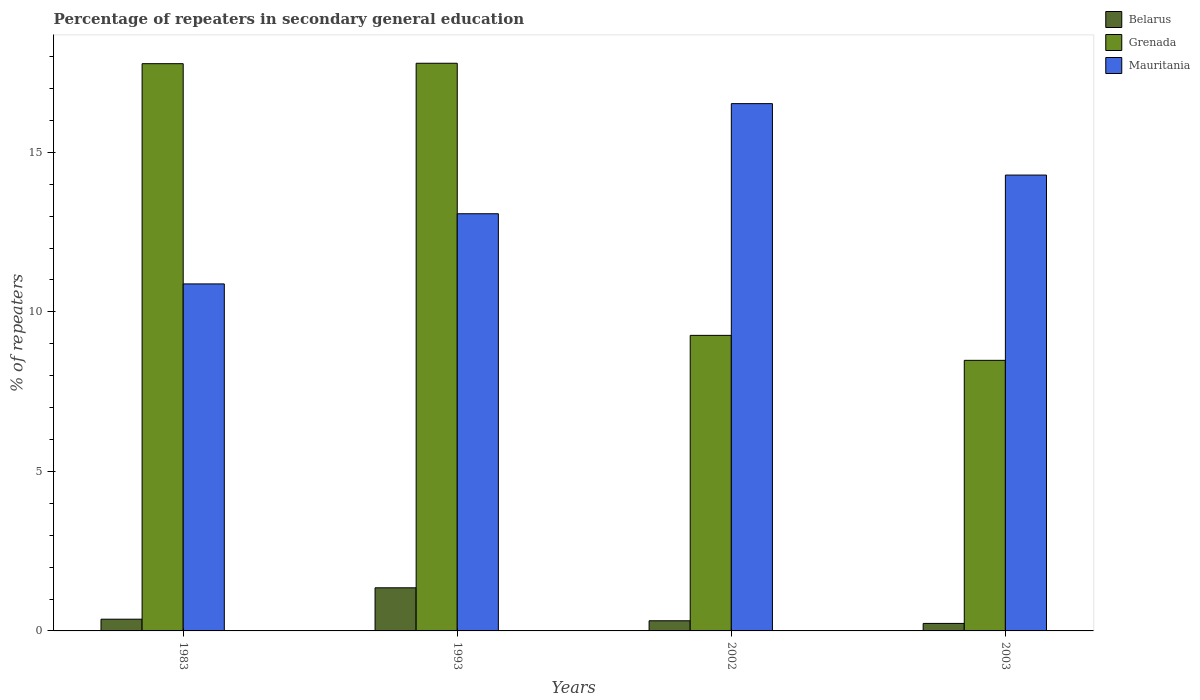How many different coloured bars are there?
Offer a terse response. 3. How many groups of bars are there?
Offer a very short reply. 4. Are the number of bars per tick equal to the number of legend labels?
Keep it short and to the point. Yes. How many bars are there on the 4th tick from the right?
Provide a succinct answer. 3. What is the label of the 1st group of bars from the left?
Keep it short and to the point. 1983. In how many cases, is the number of bars for a given year not equal to the number of legend labels?
Make the answer very short. 0. What is the percentage of repeaters in secondary general education in Belarus in 1993?
Give a very brief answer. 1.35. Across all years, what is the maximum percentage of repeaters in secondary general education in Mauritania?
Ensure brevity in your answer.  16.53. Across all years, what is the minimum percentage of repeaters in secondary general education in Mauritania?
Your response must be concise. 10.88. In which year was the percentage of repeaters in secondary general education in Belarus minimum?
Give a very brief answer. 2003. What is the total percentage of repeaters in secondary general education in Grenada in the graph?
Offer a terse response. 53.31. What is the difference between the percentage of repeaters in secondary general education in Mauritania in 2002 and that in 2003?
Your response must be concise. 2.24. What is the difference between the percentage of repeaters in secondary general education in Belarus in 2003 and the percentage of repeaters in secondary general education in Grenada in 2002?
Give a very brief answer. -9.03. What is the average percentage of repeaters in secondary general education in Grenada per year?
Your answer should be very brief. 13.33. In the year 1993, what is the difference between the percentage of repeaters in secondary general education in Grenada and percentage of repeaters in secondary general education in Belarus?
Your answer should be compact. 16.44. What is the ratio of the percentage of repeaters in secondary general education in Belarus in 1983 to that in 2003?
Provide a succinct answer. 1.56. Is the difference between the percentage of repeaters in secondary general education in Grenada in 1983 and 2002 greater than the difference between the percentage of repeaters in secondary general education in Belarus in 1983 and 2002?
Ensure brevity in your answer.  Yes. What is the difference between the highest and the second highest percentage of repeaters in secondary general education in Grenada?
Your answer should be compact. 0.01. What is the difference between the highest and the lowest percentage of repeaters in secondary general education in Grenada?
Your response must be concise. 9.31. In how many years, is the percentage of repeaters in secondary general education in Belarus greater than the average percentage of repeaters in secondary general education in Belarus taken over all years?
Provide a short and direct response. 1. Is the sum of the percentage of repeaters in secondary general education in Belarus in 2002 and 2003 greater than the maximum percentage of repeaters in secondary general education in Grenada across all years?
Make the answer very short. No. What does the 2nd bar from the left in 1983 represents?
Keep it short and to the point. Grenada. What does the 3rd bar from the right in 2002 represents?
Keep it short and to the point. Belarus. Are all the bars in the graph horizontal?
Keep it short and to the point. No. What is the difference between two consecutive major ticks on the Y-axis?
Offer a terse response. 5. Does the graph contain grids?
Your answer should be very brief. No. Where does the legend appear in the graph?
Offer a terse response. Top right. What is the title of the graph?
Give a very brief answer. Percentage of repeaters in secondary general education. What is the label or title of the X-axis?
Offer a terse response. Years. What is the label or title of the Y-axis?
Make the answer very short. % of repeaters. What is the % of repeaters in Belarus in 1983?
Give a very brief answer. 0.37. What is the % of repeaters in Grenada in 1983?
Keep it short and to the point. 17.78. What is the % of repeaters in Mauritania in 1983?
Make the answer very short. 10.88. What is the % of repeaters in Belarus in 1993?
Ensure brevity in your answer.  1.35. What is the % of repeaters of Grenada in 1993?
Offer a very short reply. 17.79. What is the % of repeaters of Mauritania in 1993?
Your answer should be compact. 13.07. What is the % of repeaters of Belarus in 2002?
Your response must be concise. 0.32. What is the % of repeaters of Grenada in 2002?
Offer a very short reply. 9.26. What is the % of repeaters of Mauritania in 2002?
Offer a very short reply. 16.53. What is the % of repeaters in Belarus in 2003?
Your answer should be very brief. 0.24. What is the % of repeaters in Grenada in 2003?
Keep it short and to the point. 8.48. What is the % of repeaters in Mauritania in 2003?
Your answer should be compact. 14.29. Across all years, what is the maximum % of repeaters of Belarus?
Keep it short and to the point. 1.35. Across all years, what is the maximum % of repeaters in Grenada?
Provide a succinct answer. 17.79. Across all years, what is the maximum % of repeaters of Mauritania?
Your answer should be compact. 16.53. Across all years, what is the minimum % of repeaters of Belarus?
Provide a succinct answer. 0.24. Across all years, what is the minimum % of repeaters in Grenada?
Offer a terse response. 8.48. Across all years, what is the minimum % of repeaters in Mauritania?
Offer a terse response. 10.88. What is the total % of repeaters of Belarus in the graph?
Give a very brief answer. 2.27. What is the total % of repeaters of Grenada in the graph?
Your response must be concise. 53.31. What is the total % of repeaters of Mauritania in the graph?
Keep it short and to the point. 54.76. What is the difference between the % of repeaters in Belarus in 1983 and that in 1993?
Provide a succinct answer. -0.98. What is the difference between the % of repeaters in Grenada in 1983 and that in 1993?
Keep it short and to the point. -0.01. What is the difference between the % of repeaters in Mauritania in 1983 and that in 1993?
Your answer should be compact. -2.2. What is the difference between the % of repeaters in Belarus in 1983 and that in 2002?
Your answer should be very brief. 0.05. What is the difference between the % of repeaters in Grenada in 1983 and that in 2002?
Provide a succinct answer. 8.52. What is the difference between the % of repeaters in Mauritania in 1983 and that in 2002?
Give a very brief answer. -5.65. What is the difference between the % of repeaters in Belarus in 1983 and that in 2003?
Provide a succinct answer. 0.13. What is the difference between the % of repeaters in Grenada in 1983 and that in 2003?
Your response must be concise. 9.3. What is the difference between the % of repeaters of Mauritania in 1983 and that in 2003?
Ensure brevity in your answer.  -3.41. What is the difference between the % of repeaters of Belarus in 1993 and that in 2002?
Provide a succinct answer. 1.03. What is the difference between the % of repeaters in Grenada in 1993 and that in 2002?
Ensure brevity in your answer.  8.53. What is the difference between the % of repeaters in Mauritania in 1993 and that in 2002?
Provide a short and direct response. -3.45. What is the difference between the % of repeaters of Belarus in 1993 and that in 2003?
Give a very brief answer. 1.12. What is the difference between the % of repeaters of Grenada in 1993 and that in 2003?
Your answer should be compact. 9.31. What is the difference between the % of repeaters in Mauritania in 1993 and that in 2003?
Your response must be concise. -1.21. What is the difference between the % of repeaters in Belarus in 2002 and that in 2003?
Your answer should be very brief. 0.08. What is the difference between the % of repeaters in Grenada in 2002 and that in 2003?
Ensure brevity in your answer.  0.78. What is the difference between the % of repeaters in Mauritania in 2002 and that in 2003?
Your answer should be very brief. 2.24. What is the difference between the % of repeaters in Belarus in 1983 and the % of repeaters in Grenada in 1993?
Keep it short and to the point. -17.42. What is the difference between the % of repeaters of Belarus in 1983 and the % of repeaters of Mauritania in 1993?
Make the answer very short. -12.71. What is the difference between the % of repeaters of Grenada in 1983 and the % of repeaters of Mauritania in 1993?
Ensure brevity in your answer.  4.7. What is the difference between the % of repeaters of Belarus in 1983 and the % of repeaters of Grenada in 2002?
Your response must be concise. -8.9. What is the difference between the % of repeaters of Belarus in 1983 and the % of repeaters of Mauritania in 2002?
Your response must be concise. -16.16. What is the difference between the % of repeaters in Grenada in 1983 and the % of repeaters in Mauritania in 2002?
Keep it short and to the point. 1.25. What is the difference between the % of repeaters in Belarus in 1983 and the % of repeaters in Grenada in 2003?
Your response must be concise. -8.11. What is the difference between the % of repeaters of Belarus in 1983 and the % of repeaters of Mauritania in 2003?
Your answer should be compact. -13.92. What is the difference between the % of repeaters of Grenada in 1983 and the % of repeaters of Mauritania in 2003?
Ensure brevity in your answer.  3.49. What is the difference between the % of repeaters in Belarus in 1993 and the % of repeaters in Grenada in 2002?
Your answer should be very brief. -7.91. What is the difference between the % of repeaters in Belarus in 1993 and the % of repeaters in Mauritania in 2002?
Your answer should be compact. -15.17. What is the difference between the % of repeaters of Grenada in 1993 and the % of repeaters of Mauritania in 2002?
Ensure brevity in your answer.  1.27. What is the difference between the % of repeaters of Belarus in 1993 and the % of repeaters of Grenada in 2003?
Make the answer very short. -7.13. What is the difference between the % of repeaters of Belarus in 1993 and the % of repeaters of Mauritania in 2003?
Give a very brief answer. -12.94. What is the difference between the % of repeaters of Grenada in 1993 and the % of repeaters of Mauritania in 2003?
Provide a succinct answer. 3.5. What is the difference between the % of repeaters in Belarus in 2002 and the % of repeaters in Grenada in 2003?
Provide a short and direct response. -8.16. What is the difference between the % of repeaters of Belarus in 2002 and the % of repeaters of Mauritania in 2003?
Provide a succinct answer. -13.97. What is the difference between the % of repeaters of Grenada in 2002 and the % of repeaters of Mauritania in 2003?
Your response must be concise. -5.02. What is the average % of repeaters in Belarus per year?
Ensure brevity in your answer.  0.57. What is the average % of repeaters of Grenada per year?
Make the answer very short. 13.33. What is the average % of repeaters of Mauritania per year?
Make the answer very short. 13.69. In the year 1983, what is the difference between the % of repeaters of Belarus and % of repeaters of Grenada?
Give a very brief answer. -17.41. In the year 1983, what is the difference between the % of repeaters of Belarus and % of repeaters of Mauritania?
Your response must be concise. -10.51. In the year 1983, what is the difference between the % of repeaters of Grenada and % of repeaters of Mauritania?
Make the answer very short. 6.9. In the year 1993, what is the difference between the % of repeaters of Belarus and % of repeaters of Grenada?
Provide a short and direct response. -16.44. In the year 1993, what is the difference between the % of repeaters of Belarus and % of repeaters of Mauritania?
Ensure brevity in your answer.  -11.72. In the year 1993, what is the difference between the % of repeaters of Grenada and % of repeaters of Mauritania?
Provide a succinct answer. 4.72. In the year 2002, what is the difference between the % of repeaters of Belarus and % of repeaters of Grenada?
Give a very brief answer. -8.94. In the year 2002, what is the difference between the % of repeaters in Belarus and % of repeaters in Mauritania?
Your answer should be compact. -16.21. In the year 2002, what is the difference between the % of repeaters in Grenada and % of repeaters in Mauritania?
Keep it short and to the point. -7.26. In the year 2003, what is the difference between the % of repeaters in Belarus and % of repeaters in Grenada?
Offer a terse response. -8.25. In the year 2003, what is the difference between the % of repeaters in Belarus and % of repeaters in Mauritania?
Your response must be concise. -14.05. In the year 2003, what is the difference between the % of repeaters of Grenada and % of repeaters of Mauritania?
Provide a succinct answer. -5.81. What is the ratio of the % of repeaters in Belarus in 1983 to that in 1993?
Provide a succinct answer. 0.27. What is the ratio of the % of repeaters in Grenada in 1983 to that in 1993?
Make the answer very short. 1. What is the ratio of the % of repeaters in Mauritania in 1983 to that in 1993?
Give a very brief answer. 0.83. What is the ratio of the % of repeaters in Belarus in 1983 to that in 2002?
Ensure brevity in your answer.  1.16. What is the ratio of the % of repeaters in Grenada in 1983 to that in 2002?
Provide a succinct answer. 1.92. What is the ratio of the % of repeaters of Mauritania in 1983 to that in 2002?
Provide a short and direct response. 0.66. What is the ratio of the % of repeaters of Belarus in 1983 to that in 2003?
Provide a succinct answer. 1.56. What is the ratio of the % of repeaters in Grenada in 1983 to that in 2003?
Provide a succinct answer. 2.1. What is the ratio of the % of repeaters of Mauritania in 1983 to that in 2003?
Provide a short and direct response. 0.76. What is the ratio of the % of repeaters in Belarus in 1993 to that in 2002?
Your answer should be compact. 4.25. What is the ratio of the % of repeaters in Grenada in 1993 to that in 2002?
Keep it short and to the point. 1.92. What is the ratio of the % of repeaters of Mauritania in 1993 to that in 2002?
Your answer should be compact. 0.79. What is the ratio of the % of repeaters of Belarus in 1993 to that in 2003?
Make the answer very short. 5.74. What is the ratio of the % of repeaters in Grenada in 1993 to that in 2003?
Your answer should be compact. 2.1. What is the ratio of the % of repeaters in Mauritania in 1993 to that in 2003?
Offer a very short reply. 0.92. What is the ratio of the % of repeaters in Belarus in 2002 to that in 2003?
Offer a very short reply. 1.35. What is the ratio of the % of repeaters in Grenada in 2002 to that in 2003?
Your answer should be very brief. 1.09. What is the ratio of the % of repeaters of Mauritania in 2002 to that in 2003?
Your response must be concise. 1.16. What is the difference between the highest and the second highest % of repeaters of Belarus?
Your answer should be very brief. 0.98. What is the difference between the highest and the second highest % of repeaters in Grenada?
Provide a short and direct response. 0.01. What is the difference between the highest and the second highest % of repeaters in Mauritania?
Give a very brief answer. 2.24. What is the difference between the highest and the lowest % of repeaters in Belarus?
Offer a terse response. 1.12. What is the difference between the highest and the lowest % of repeaters in Grenada?
Your answer should be very brief. 9.31. What is the difference between the highest and the lowest % of repeaters of Mauritania?
Provide a succinct answer. 5.65. 